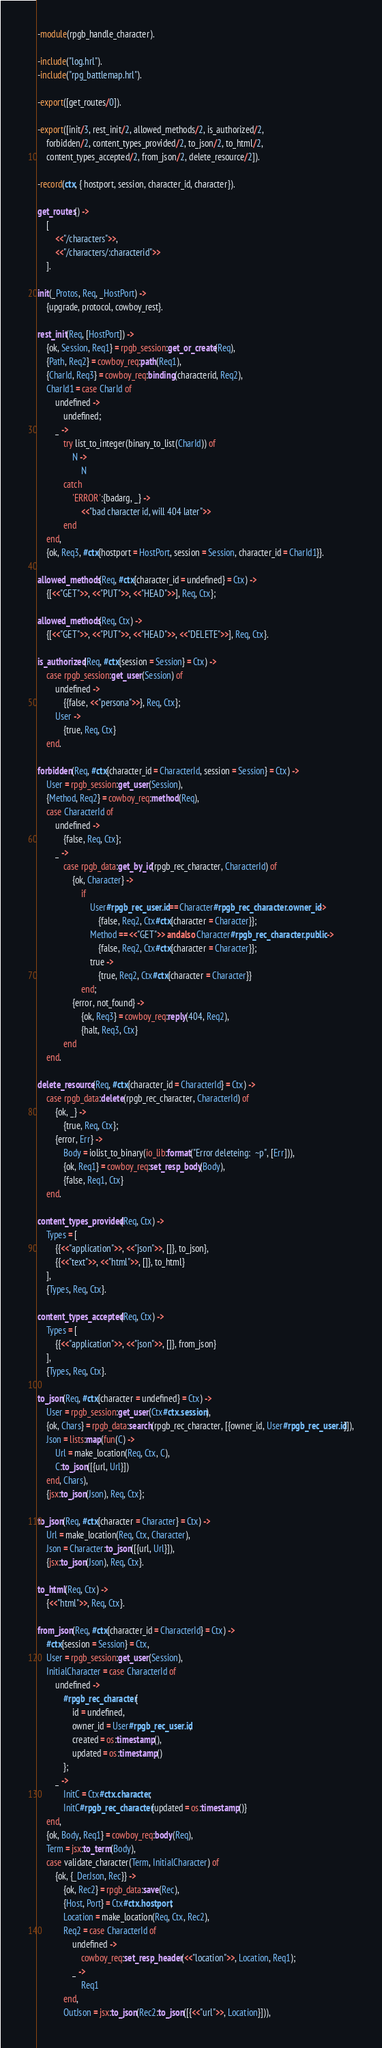<code> <loc_0><loc_0><loc_500><loc_500><_Erlang_>-module(rpgb_handle_character).

-include("log.hrl").
-include("rpg_battlemap.hrl").

-export([get_routes/0]).

-export([init/3, rest_init/2, allowed_methods/2, is_authorized/2,
	forbidden/2, content_types_provided/2, to_json/2, to_html/2,
	content_types_accepted/2, from_json/2, delete_resource/2]).

-record(ctx, { hostport, session, character_id, character}).

get_routes() ->
	[
		<<"/characters">>,
		<<"/characters/:characterid">>
	].

init(_Protos, Req, _HostPort) ->
	{upgrade, protocol, cowboy_rest}.

rest_init(Req, [HostPort]) ->
	{ok, Session, Req1} = rpgb_session:get_or_create(Req),
	{Path, Req2} = cowboy_req:path(Req1),
	{CharId, Req3} = cowboy_req:binding(characterid, Req2),
	CharId1 = case CharId of
		undefined ->
			undefined;
		_ ->
			try list_to_integer(binary_to_list(CharId)) of
				N ->
					N
			catch
				'ERROR':{badarg, _} ->
					<<"bad character id, will 404 later">>
			end
	end,
	{ok, Req3, #ctx{hostport = HostPort, session = Session, character_id = CharId1}}.

allowed_methods(Req, #ctx{character_id = undefined} = Ctx) ->
	{[<<"GET">>, <<"PUT">>, <<"HEAD">>], Req, Ctx};

allowed_methods(Req, Ctx) ->
	{[<<"GET">>, <<"PUT">>, <<"HEAD">>, <<"DELETE">>], Req, Ctx}.

is_authorized(Req, #ctx{session = Session} = Ctx) ->
	case rpgb_session:get_user(Session) of
		undefined ->
			{{false, <<"persona">>}, Req, Ctx};
		User ->
			{true, Req, Ctx}
	end.

forbidden(Req, #ctx{character_id = CharacterId, session = Session} = Ctx) ->
	User = rpgb_session:get_user(Session),
	{Method, Req2} = cowboy_req:method(Req),
	case CharacterId of
		undefined ->
			{false, Req, Ctx};
		_ ->
			case rpgb_data:get_by_id(rpgb_rec_character, CharacterId) of
				{ok, Character} ->
					if
						User#rpgb_rec_user.id == Character#rpgb_rec_character.owner_id ->
							{false, Req2, Ctx#ctx{character = Character}};
						Method == <<"GET">> andalso Character#rpgb_rec_character.public ->
							{false, Req2, Ctx#ctx{character = Character}};
						true ->
							{true, Req2, Ctx#ctx{character = Character}}
					end;
				{error, not_found} ->
					{ok, Req3} = cowboy_req:reply(404, Req2),
					{halt, Req3, Ctx}
			end
	end.

delete_resource(Req, #ctx{character_id = CharacterId} = Ctx) ->
	case rpgb_data:delete(rpgb_rec_character, CharacterId) of
		{ok, _} ->
			{true, Req, Ctx};
		{error, Err} ->
			Body = iolist_to_binary(io_lib:format("Error deleteing:  ~p", [Err])),
			{ok, Req1} = cowboy_req:set_resp_body(Body),
			{false, Req1, Ctx}
	end.

content_types_provided(Req, Ctx) ->
	Types = [
		{{<<"application">>, <<"json">>, []}, to_json},
		{{<<"text">>, <<"html">>, []}, to_html}
	],
	{Types, Req, Ctx}.

content_types_accepted(Req, Ctx) ->
	Types = [
		{{<<"application">>, <<"json">>, []}, from_json}
	],
	{Types, Req, Ctx}.

to_json(Req, #ctx{character = undefined} = Ctx) ->
	User = rpgb_session:get_user(Ctx#ctx.session),
	{ok, Chars} = rpgb_data:search(rpgb_rec_character, [{owner_id, User#rpgb_rec_user.id}]),
	Json = lists:map(fun(C) ->
		Url = make_location(Req, Ctx, C),
		C:to_json([{url, Url}])
	end, Chars),
	{jsx:to_json(Json), Req, Ctx};

to_json(Req, #ctx{character = Character} = Ctx) ->
	Url = make_location(Req, Ctx, Character),
	Json = Character:to_json([{url, Url}]),
	{jsx:to_json(Json), Req, Ctx}.

to_html(Req, Ctx) ->
	{<<"html">>, Req, Ctx}.

from_json(Req, #ctx{character_id = CharacterId} = Ctx) ->
	#ctx{session = Session} = Ctx,
	User = rpgb_session:get_user(Session),
	InitialCharacter = case CharacterId of
		undefined ->
			#rpgb_rec_character{
				id = undefined,
				owner_id = User#rpgb_rec_user.id,
				created = os:timestamp(),
				updated = os:timestamp()
			};
		_ ->
			InitC = Ctx#ctx.character,
			InitC#rpgb_rec_character{updated = os:timestamp()}
	end,
	{ok, Body, Req1} = cowboy_req:body(Req),
	Term = jsx:to_term(Body),
	case validate_character(Term, InitialCharacter) of
		{ok, {_DerJson, Rec}} ->
			{ok, Rec2} = rpgb_data:save(Rec),
			{Host, Port} = Ctx#ctx.hostport,
			Location = make_location(Req, Ctx, Rec2),
			Req2 = case CharacterId of
				undefined ->
					cowboy_req:set_resp_header(<<"location">>, Location, Req1);
				_ ->
					Req1
			end,
			OutJson = jsx:to_json(Rec2:to_json([{<<"url">>, Location}])),</code> 